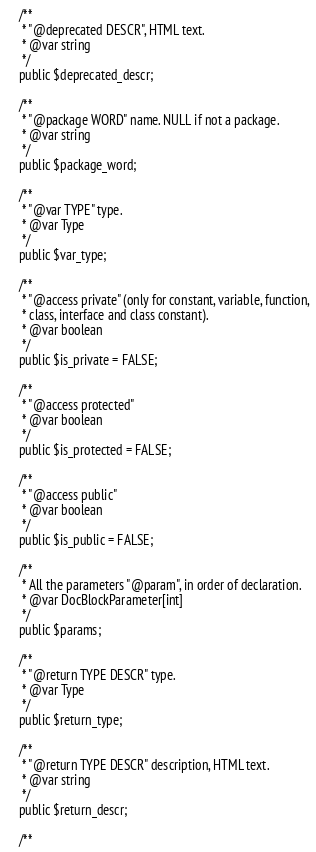Convert code to text. <code><loc_0><loc_0><loc_500><loc_500><_PHP_>	/**
	 * "@deprecated DESCR", HTML text.
	 * @var string 
	 */
	public $deprecated_descr;

	/**
	 * "@package WORD" name. NULL if not a package.
	 * @var string
	 */
	public $package_word;

	/**
	 * "@var TYPE" type.
	 * @var Type
	 */
	public $var_type;

	/**
	 * "@access private" (only for constant, variable, function,
	 * class, interface and class constant).
	 * @var boolean
	 */
	public $is_private = FALSE;

	/**
	 * "@access protected"
	 * @var boolean
	 */
	public $is_protected = FALSE;

	/**
	 * "@access public"
	 * @var boolean
	 */
	public $is_public = FALSE;

	/**
	 * All the parameters "@param", in order of declaration.
	 * @var DocBlockParameter[int]
	 */
	public $params;

	/**
	 * "@return TYPE DESCR" type.
	 * @var Type
	 */
	public $return_type;

	/**
	 * "@return TYPE DESCR" description, HTML text.
	 * @var string
	 */
	public $return_descr;
	
	/**</code> 